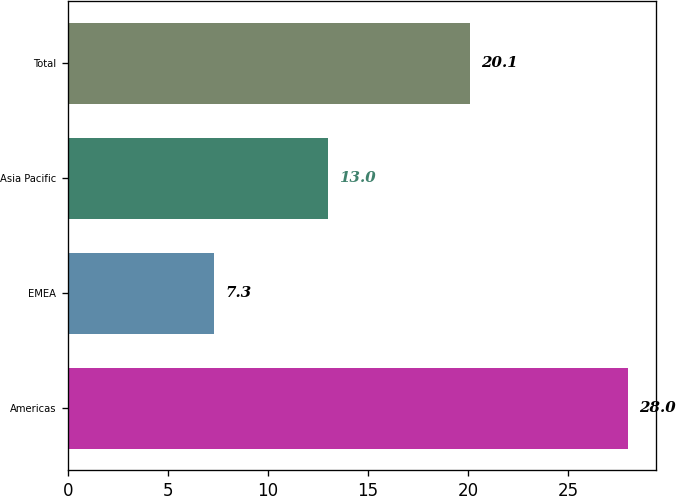<chart> <loc_0><loc_0><loc_500><loc_500><bar_chart><fcel>Americas<fcel>EMEA<fcel>Asia Pacific<fcel>Total<nl><fcel>28<fcel>7.3<fcel>13<fcel>20.1<nl></chart> 